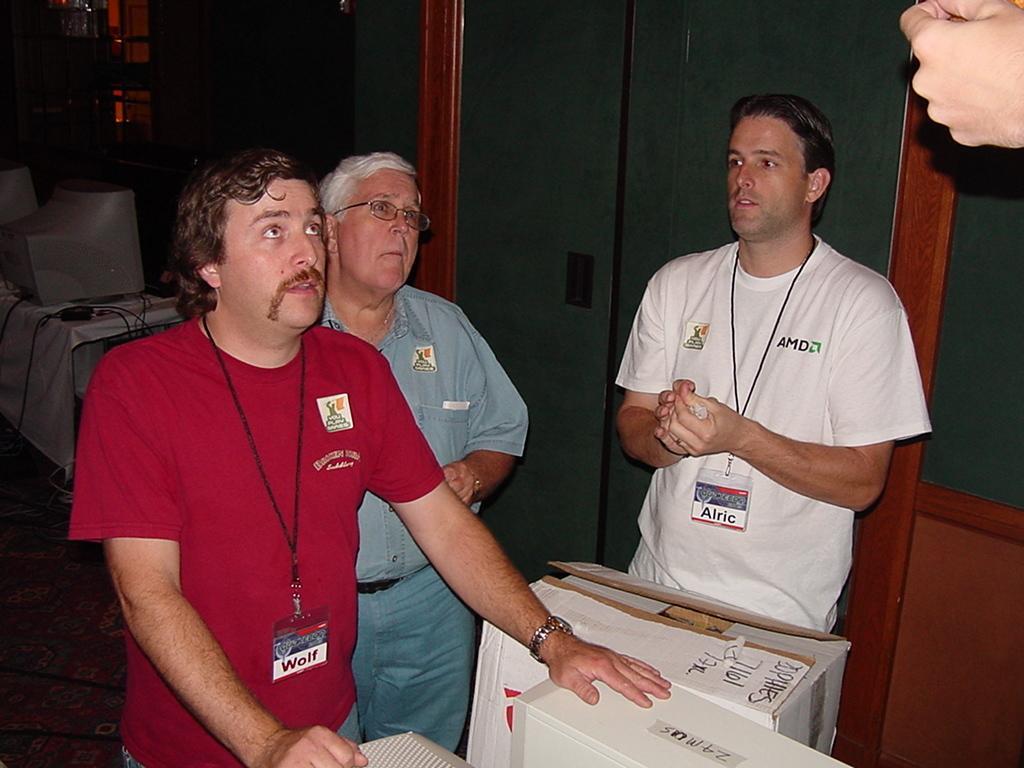In one or two sentences, can you explain what this image depicts? In this image we can see a few people standing, we can see the cardboard box, few objects, we can see the few objects on the table, on the right we can see the glass door. 